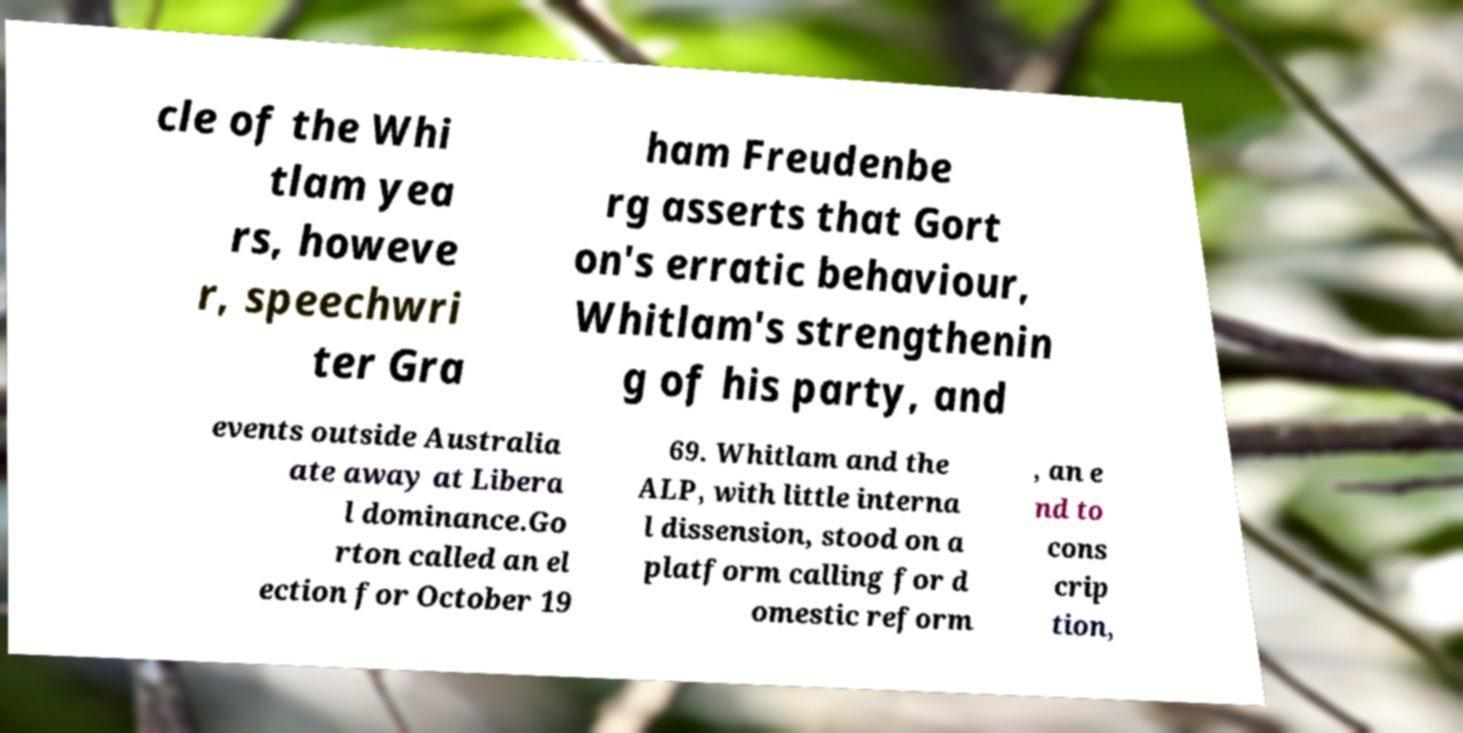Please read and relay the text visible in this image. What does it say? cle of the Whi tlam yea rs, howeve r, speechwri ter Gra ham Freudenbe rg asserts that Gort on's erratic behaviour, Whitlam's strengthenin g of his party, and events outside Australia ate away at Libera l dominance.Go rton called an el ection for October 19 69. Whitlam and the ALP, with little interna l dissension, stood on a platform calling for d omestic reform , an e nd to cons crip tion, 